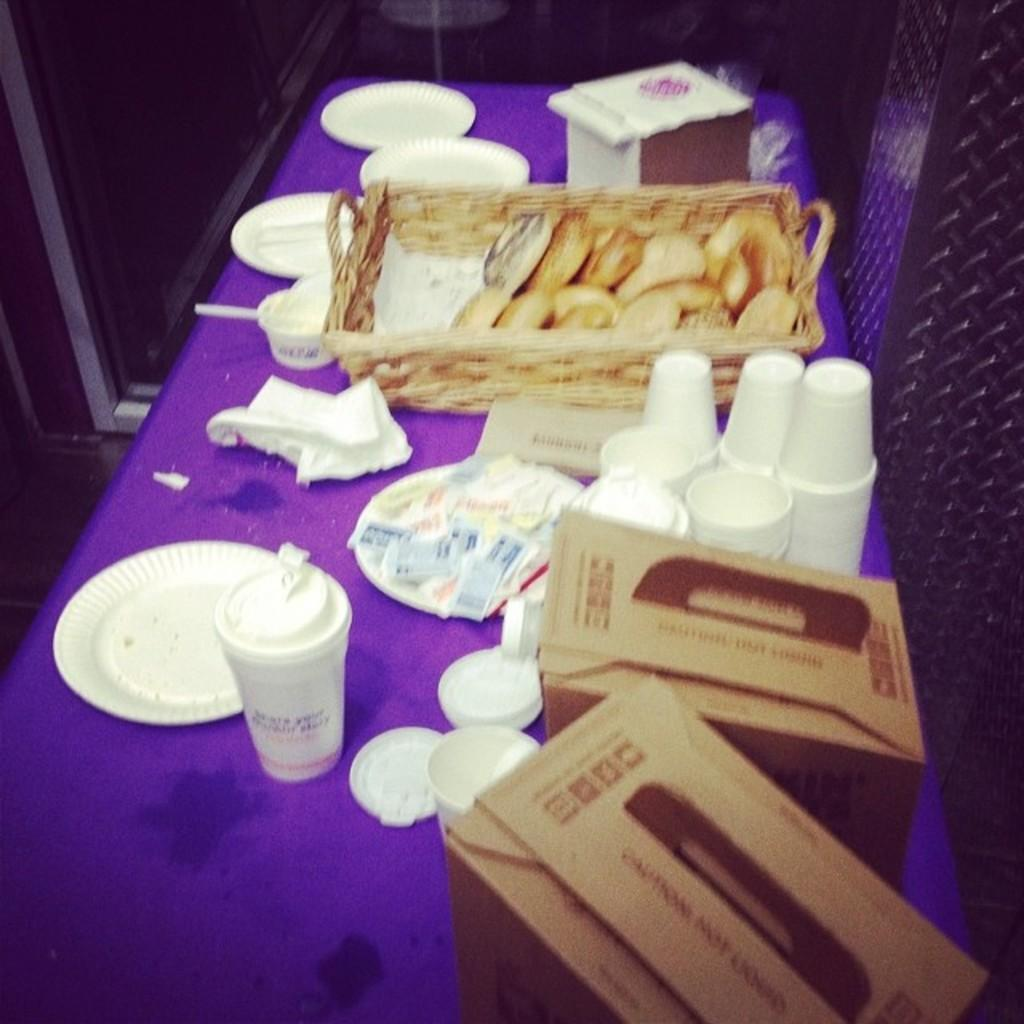What type of food items are in the basket in the image? There are snacks in a basket in the image. What other items can be seen on the table in the image? There are boxes, cups, plates, and papers visible on the table in the image. Can you describe the objects on the table in more detail? There are other objects on the table in the image, but their specific nature is not mentioned in the provided facts. What is visible in the background of the image? There are stands visible in the background of the image. How does the swing in the image affect the shock of the objects on the table? There is no swing present in the image, so this question cannot be answered. 